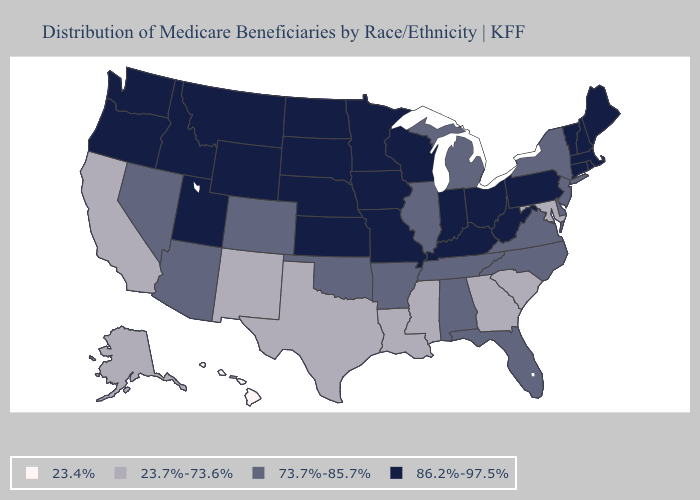Does Illinois have the highest value in the MidWest?
Give a very brief answer. No. What is the value of Hawaii?
Quick response, please. 23.4%. What is the value of Utah?
Give a very brief answer. 86.2%-97.5%. What is the value of Pennsylvania?
Give a very brief answer. 86.2%-97.5%. Which states have the lowest value in the Northeast?
Keep it brief. New Jersey, New York. Does the first symbol in the legend represent the smallest category?
Answer briefly. Yes. What is the highest value in the West ?
Quick response, please. 86.2%-97.5%. What is the value of New Jersey?
Write a very short answer. 73.7%-85.7%. Name the states that have a value in the range 73.7%-85.7%?
Quick response, please. Alabama, Arizona, Arkansas, Colorado, Delaware, Florida, Illinois, Michigan, Nevada, New Jersey, New York, North Carolina, Oklahoma, Tennessee, Virginia. Which states hav the highest value in the West?
Answer briefly. Idaho, Montana, Oregon, Utah, Washington, Wyoming. What is the highest value in the USA?
Short answer required. 86.2%-97.5%. Does Minnesota have the same value as Connecticut?
Concise answer only. Yes. What is the value of South Dakota?
Quick response, please. 86.2%-97.5%. Does Illinois have the lowest value in the MidWest?
Write a very short answer. Yes. 